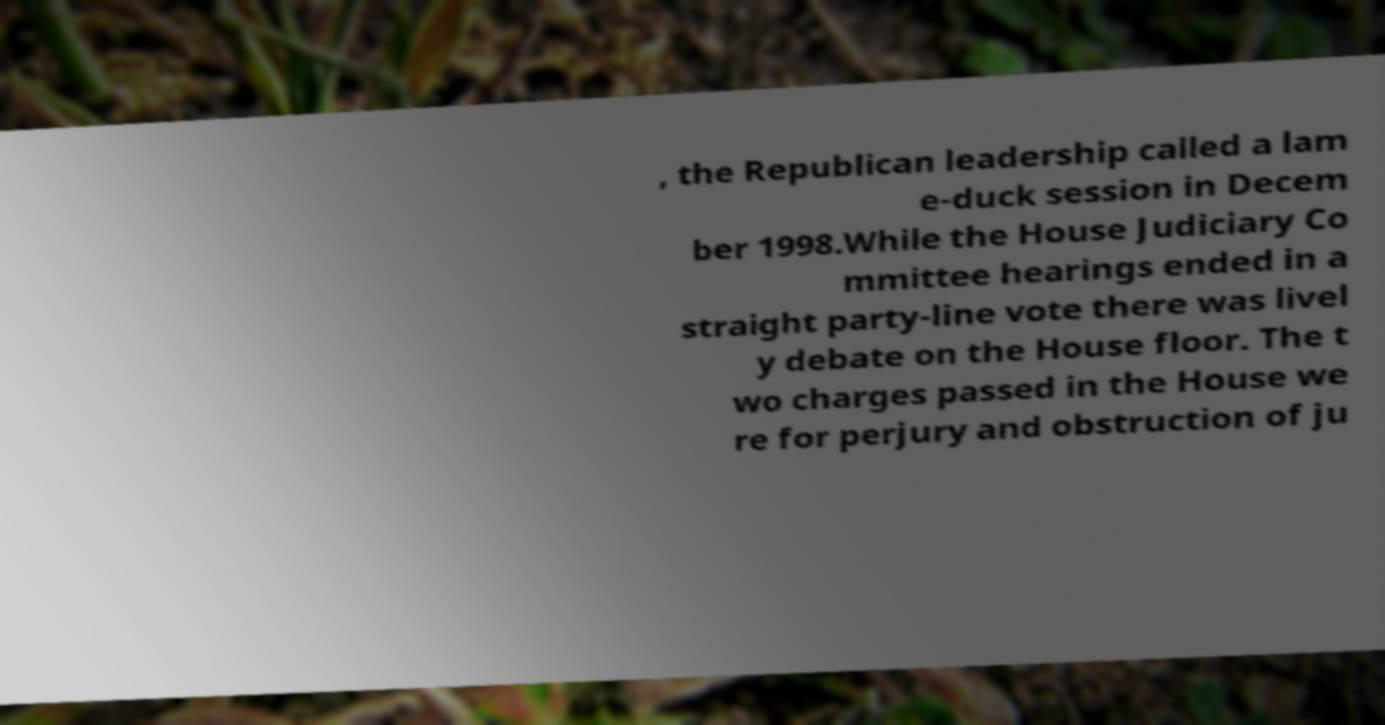I need the written content from this picture converted into text. Can you do that? , the Republican leadership called a lam e-duck session in Decem ber 1998.While the House Judiciary Co mmittee hearings ended in a straight party-line vote there was livel y debate on the House floor. The t wo charges passed in the House we re for perjury and obstruction of ju 